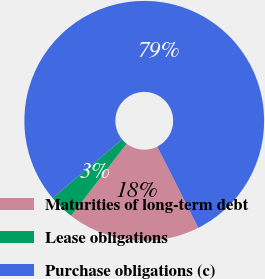Convert chart. <chart><loc_0><loc_0><loc_500><loc_500><pie_chart><fcel>Maturities of long-term debt<fcel>Lease obligations<fcel>Purchase obligations (c)<nl><fcel>17.88%<fcel>3.42%<fcel>78.7%<nl></chart> 